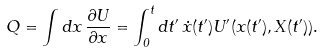Convert formula to latex. <formula><loc_0><loc_0><loc_500><loc_500>Q = \int d x \, \frac { \partial U } { \partial x } = \int _ { 0 } ^ { t } d t ^ { \prime } \, \dot { x } ( t ^ { \prime } ) U ^ { \prime } ( x ( t ^ { \prime } ) , X ( t ^ { \prime } ) ) .</formula> 